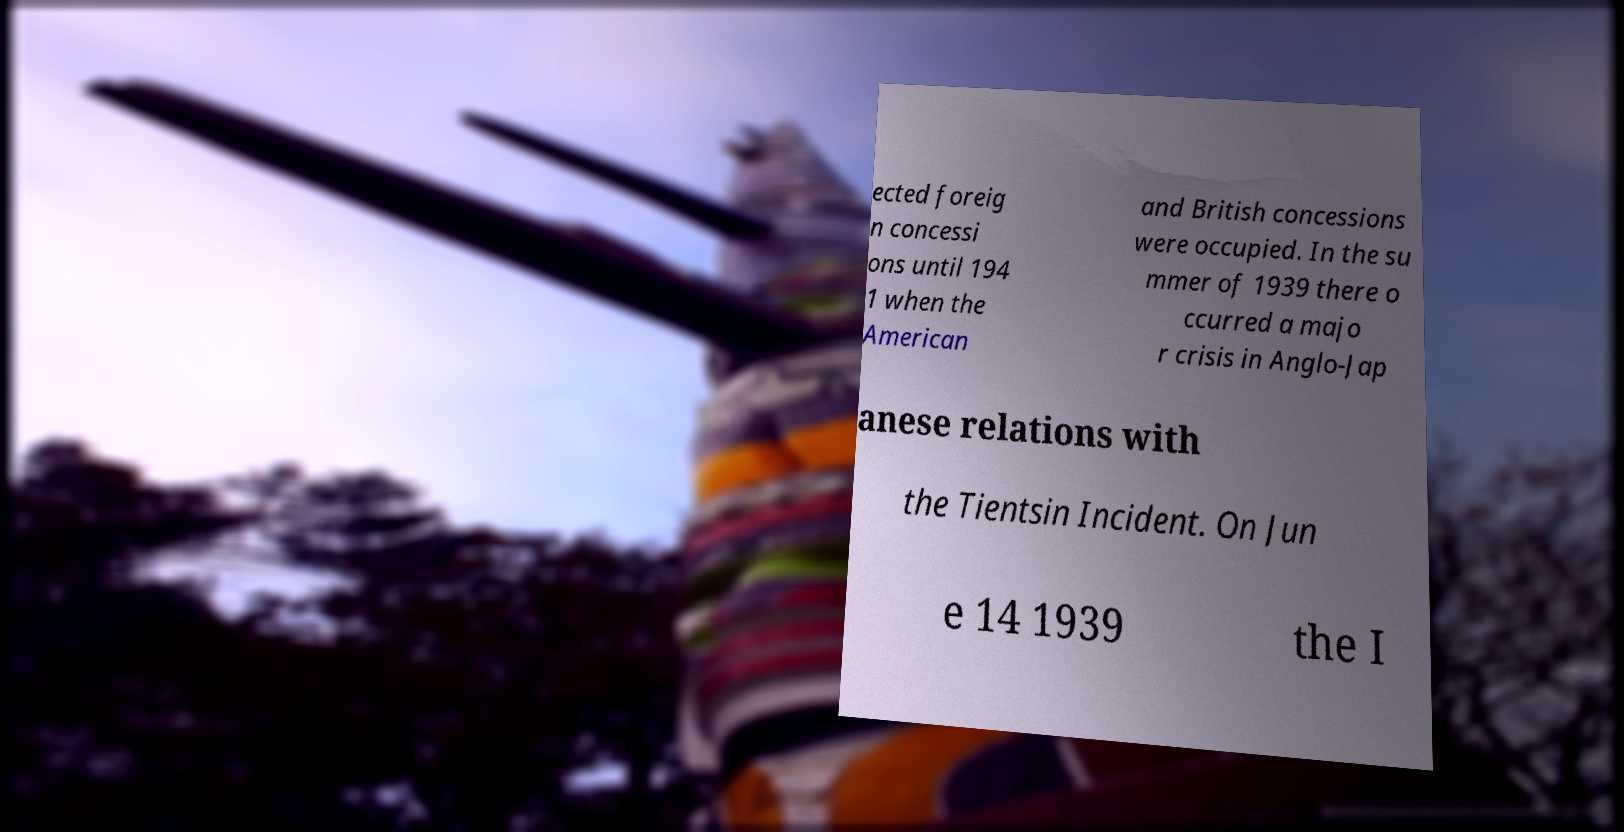Could you extract and type out the text from this image? ected foreig n concessi ons until 194 1 when the American and British concessions were occupied. In the su mmer of 1939 there o ccurred a majo r crisis in Anglo-Jap anese relations with the Tientsin Incident. On Jun e 14 1939 the I 